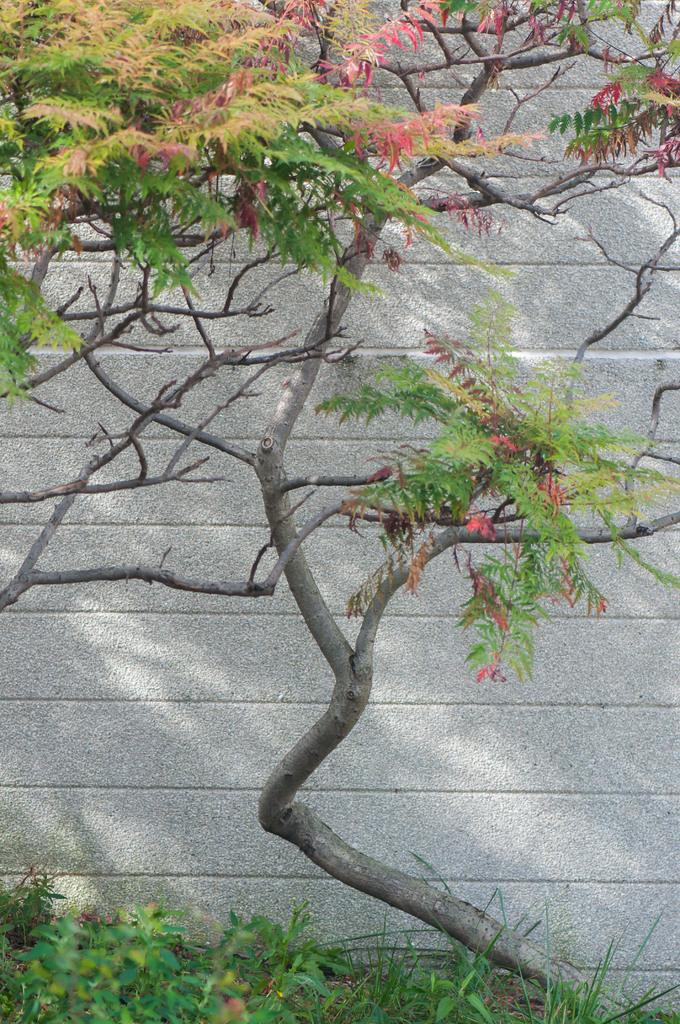What type of vegetation is at the bottom of the image? There are plants at the bottom of the image. Can you describe another type of vegetation in the image? There is a tree in the image. What structure is visible in the image? There is a wall visible in the image. What type of print can be seen on the tree in the image? There is no print visible on the tree in the image; it is a natural tree. What type of dinner is being served in the image? There is no dinner present in the image; it features plants, a tree, and a wall. 